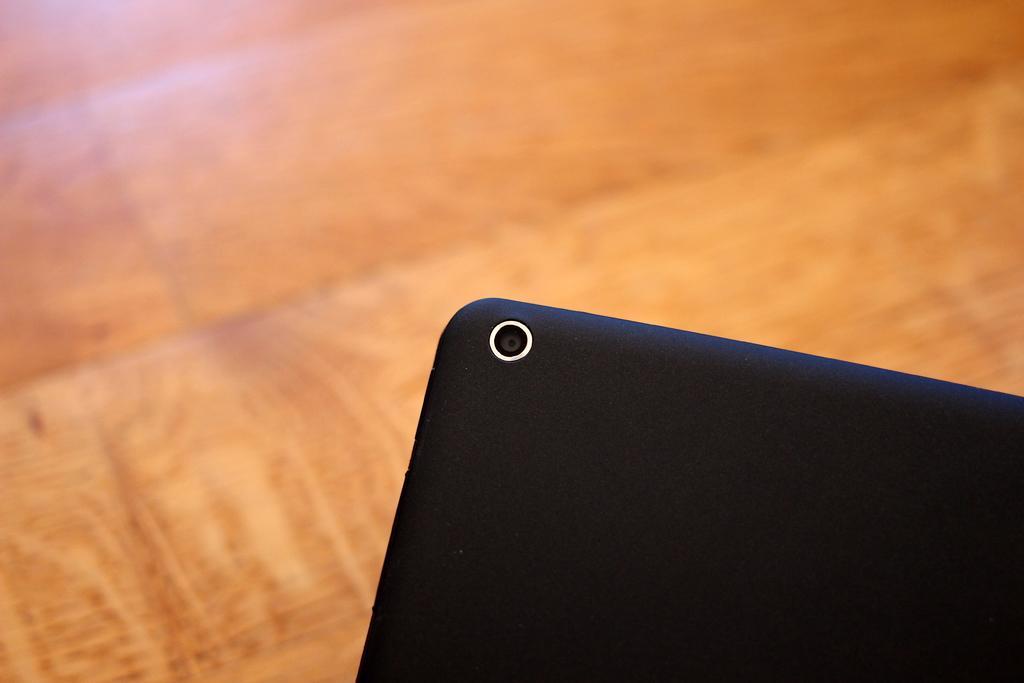Could you give a brief overview of what you see in this image? In this picture we can see a device and in the background we can see the surface. 